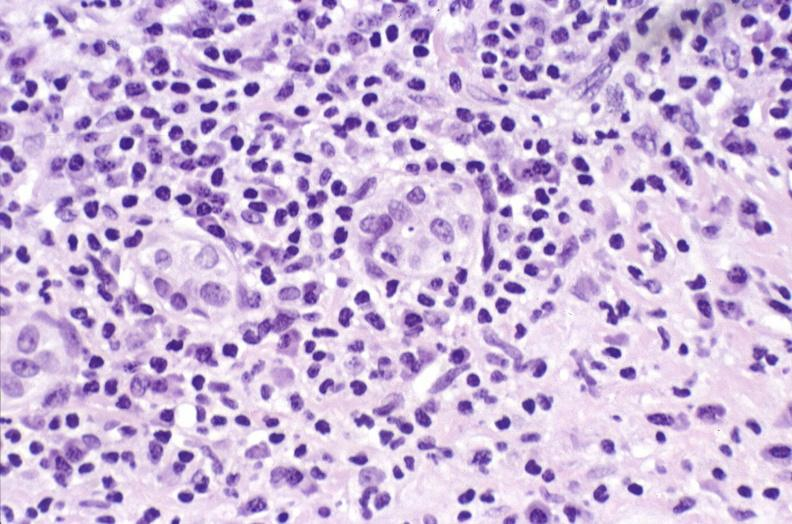what is present?
Answer the question using a single word or phrase. Hepatobiliary 